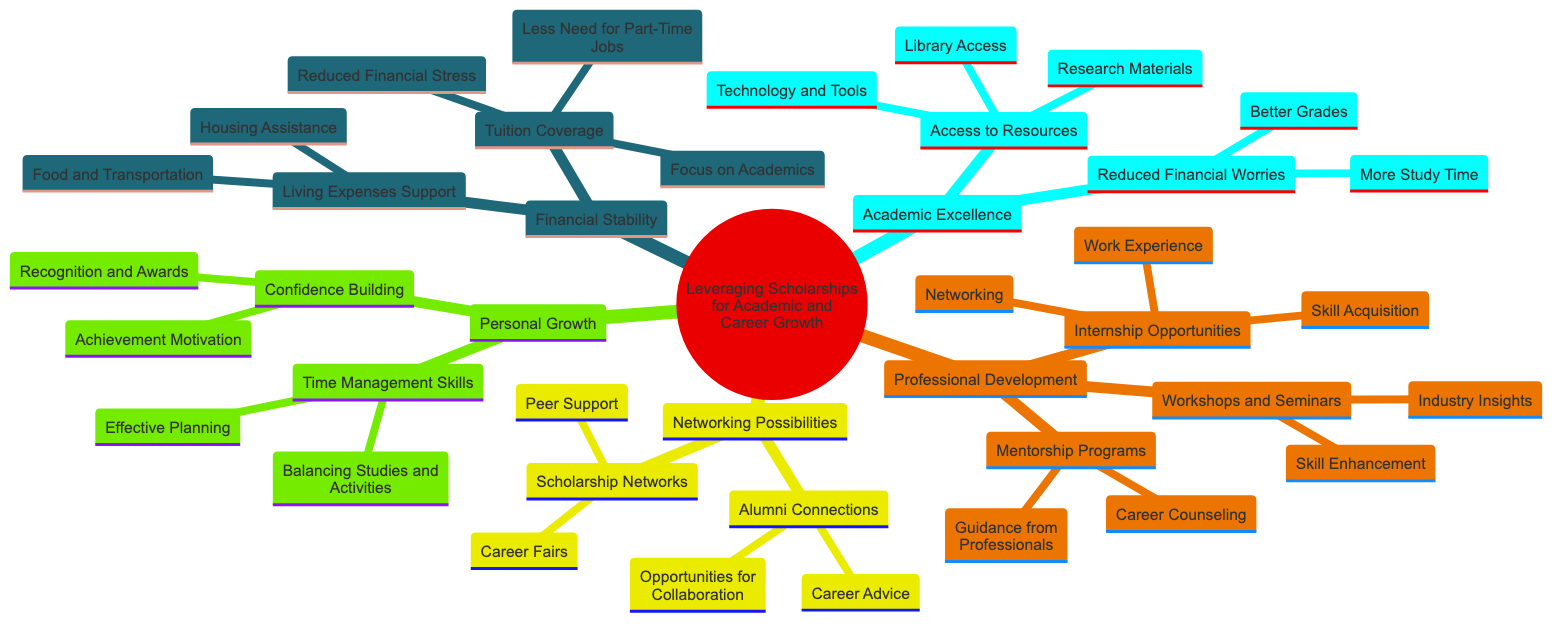What is the central concept of the diagram? The title of the diagram, represented at the root node, identifies the main idea it covers, which is "Leveraging Scholarships for Academic and Career Growth."
Answer: Leveraging Scholarships for Academic and Career Growth How many main elements are there in the concept map? The concept map has five main elements branching out from the central concept: Financial Stability, Academic Excellence, Professional Development, Networking Possibilities, and Personal Growth.
Answer: 5 What is one sub-element of Academic Excellence? Under the Academic Excellence element, there are two sub-elements identified: Access to Resources and Reduced Financial Worries. Access to Resources is one of them.
Answer: Access to Resources Which element includes Living Expenses Support? Upon examining the diagram, Living Expenses Support falls under the main element of Financial Stability, indicating its role in ensuring financial support for students.
Answer: Financial Stability What are two benefits listed under Tuition Coverage? The sub-element Tuition Coverage has three benefits, two of which are Reduced Financial Stress and Focus on Academics.
Answer: Reduced Financial Stress, Focus on Academics Which type of opportunities does Professional Development encompass? The element of Professional Development includes three types of opportunities: Internship Opportunities, Mentorship Programs, and Workshops and Seminars. The first type, Internship Opportunities, is included in the element.
Answer: Internship Opportunities How does Networking Possibilities contribute to career growth? Networking Possibilities contributes through its two sub-elements: Alumni Connections and Scholarship Networks. Both provide critical social supports that can lead to job opportunities and advice, showing the role of networking in career development.
Answer: Alumni Connections, Scholarship Networks What is one aspect of Personal Growth related to time management? Personal Growth contains a sub-element named Time Management Skills, which highlights the importance of managing time effectively.
Answer: Time Management Skills How does the diagram illustrate the relationship between financial stability and academic excellence? The connection between Financial Stability and Academic Excellence indicates that better financial support leads to reduced worries about expenses, promoting a stronger focus on academic performance.
Answer: Financial support promotes academic performance 